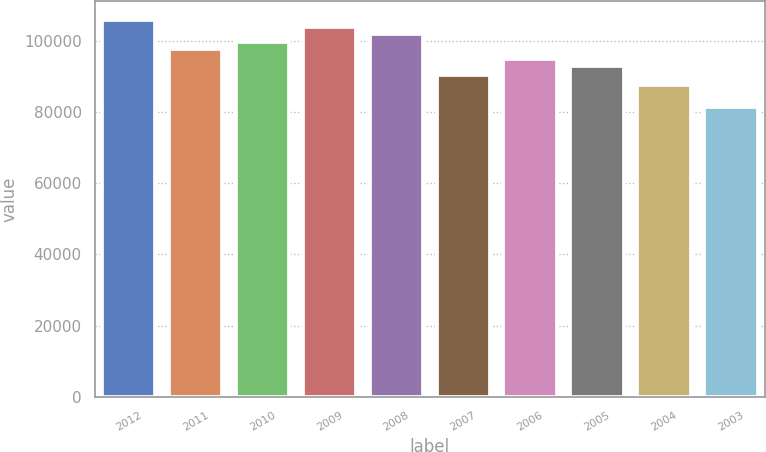Convert chart. <chart><loc_0><loc_0><loc_500><loc_500><bar_chart><fcel>2012<fcel>2011<fcel>2010<fcel>2009<fcel>2008<fcel>2007<fcel>2006<fcel>2005<fcel>2004<fcel>2003<nl><fcel>105792<fcel>97682<fcel>99709.5<fcel>103764<fcel>101737<fcel>90382<fcel>94799<fcel>92744<fcel>87639<fcel>81361<nl></chart> 